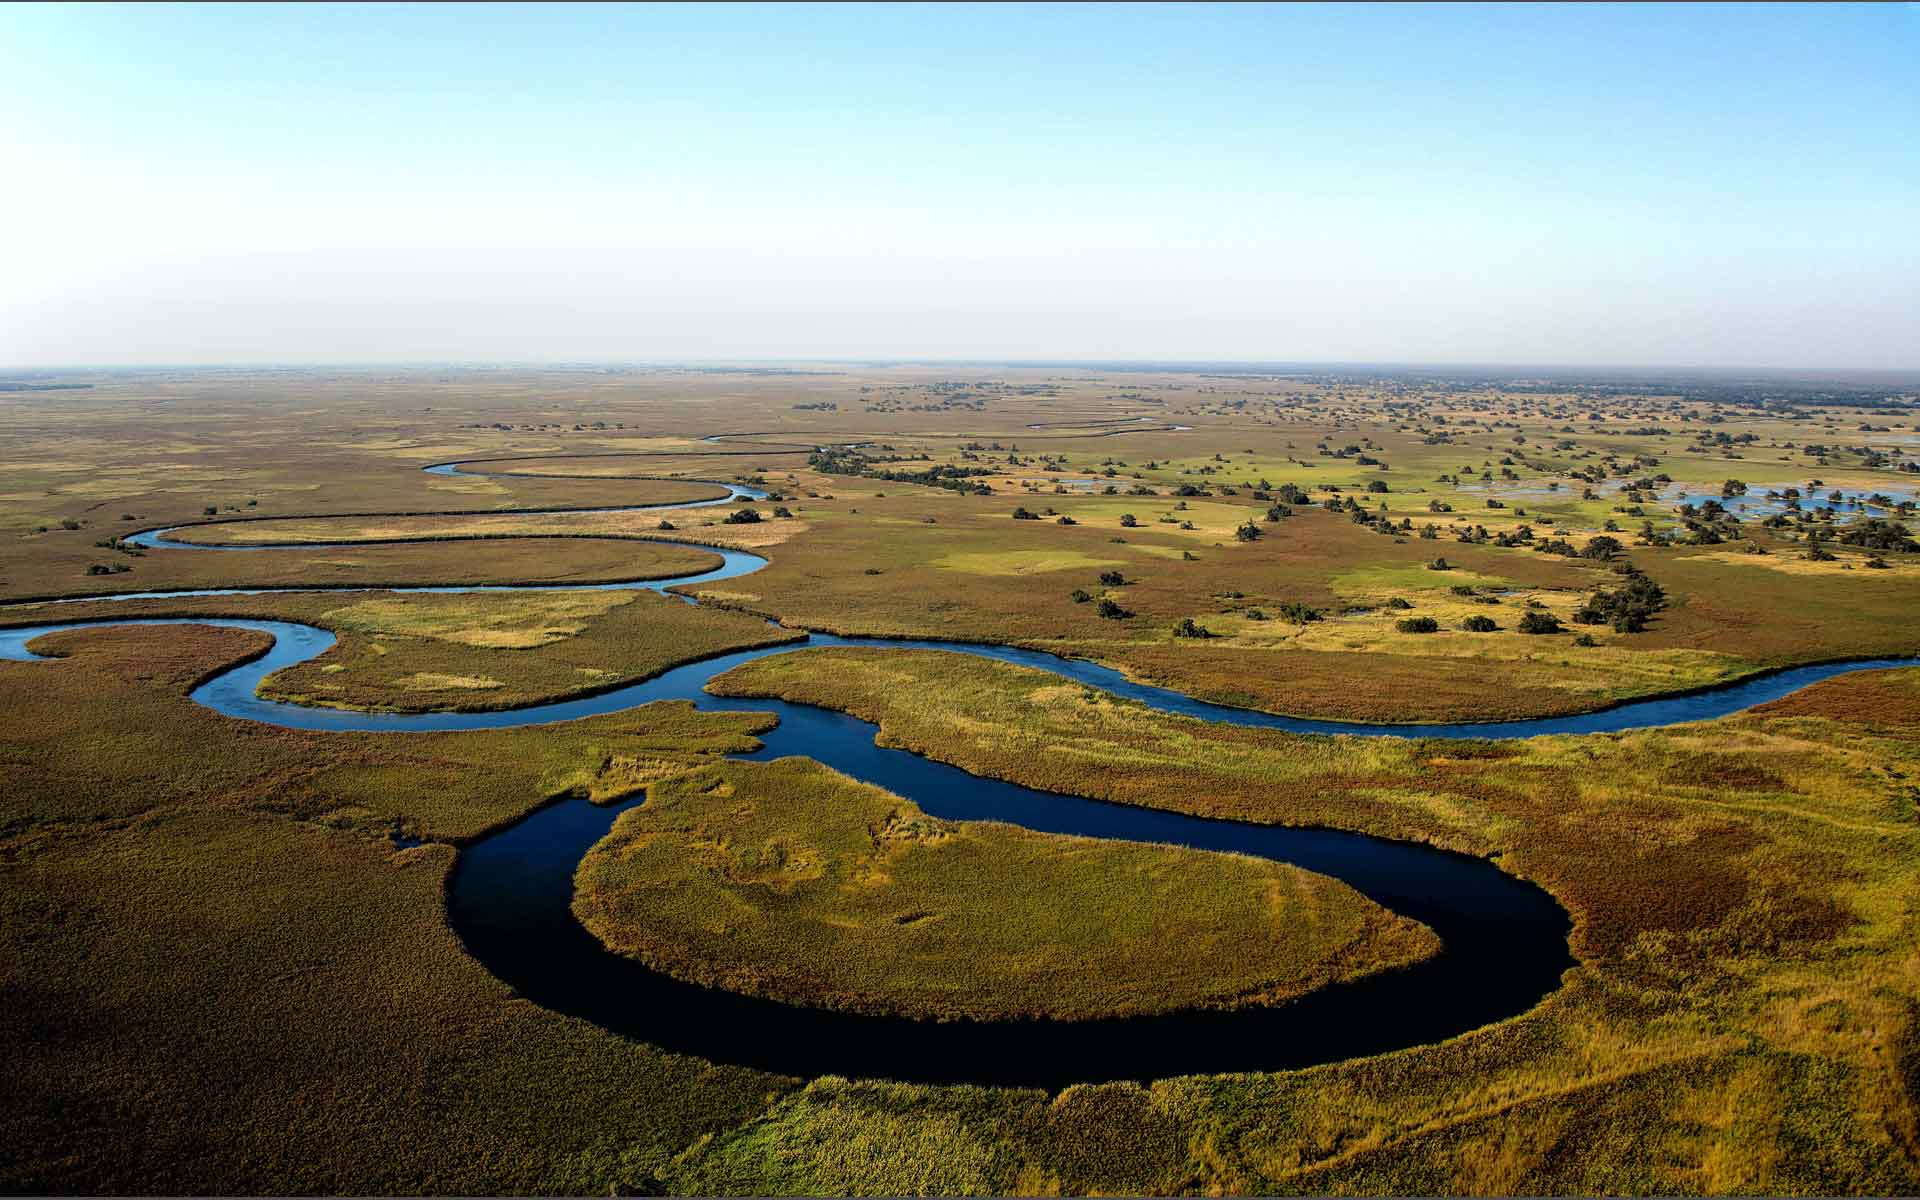What kind of unique wildlife might one expect to see in this ecosystem? The Okavango Delta is a biodiversity hotspot, home to an array of unique and diverse species. Visitors can expect to see large African elephants, which frequently bathe in the delta's waters, and the elusive sitatunga antelope, adapted to the aquatic environment with elongated, splayed hooves. The delta also provides refuge to lions, cheetahs, and leopards. Bird enthusiasts will find the area particularly enchanting, with over 400 recorded bird species, including the iconic African fish eagle and the rare Pel's fishing owl. 